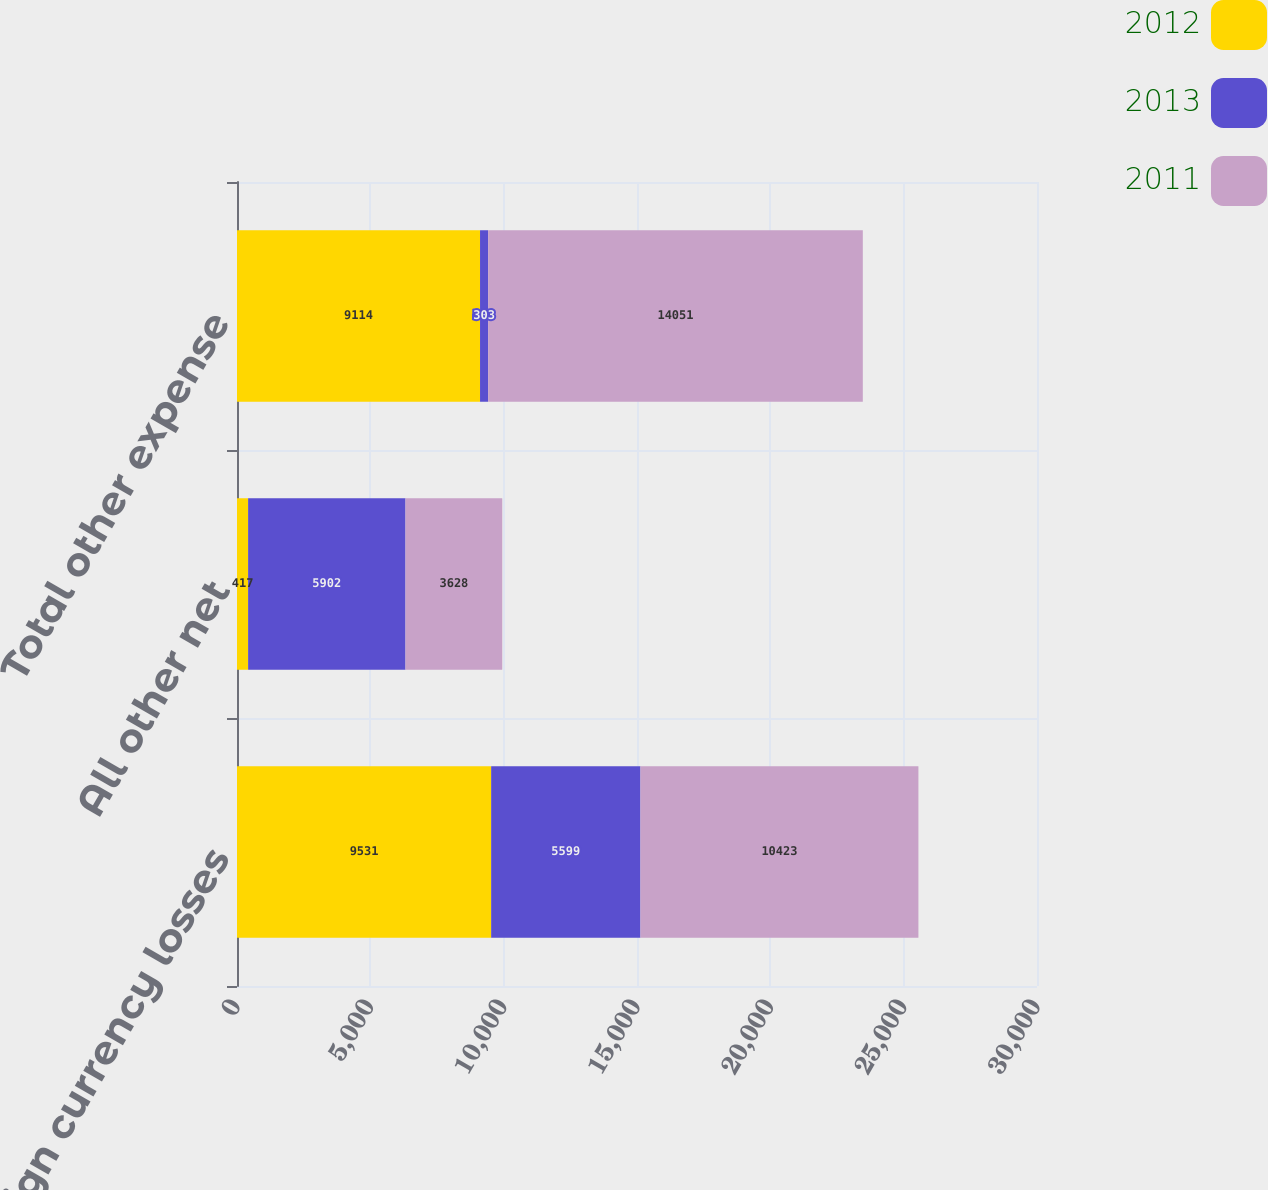Convert chart. <chart><loc_0><loc_0><loc_500><loc_500><stacked_bar_chart><ecel><fcel>Foreign currency losses<fcel>All other net<fcel>Total other expense<nl><fcel>2012<fcel>9531<fcel>417<fcel>9114<nl><fcel>2013<fcel>5599<fcel>5902<fcel>303<nl><fcel>2011<fcel>10423<fcel>3628<fcel>14051<nl></chart> 